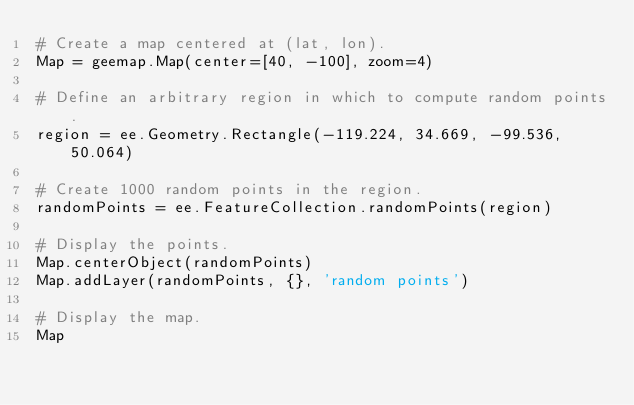<code> <loc_0><loc_0><loc_500><loc_500><_Python_># Create a map centered at (lat, lon).
Map = geemap.Map(center=[40, -100], zoom=4)

# Define an arbitrary region in which to compute random points.
region = ee.Geometry.Rectangle(-119.224, 34.669, -99.536, 50.064)

# Create 1000 random points in the region.
randomPoints = ee.FeatureCollection.randomPoints(region)

# Display the points.
Map.centerObject(randomPoints)
Map.addLayer(randomPoints, {}, 'random points')

# Display the map.
Map
</code> 